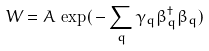Convert formula to latex. <formula><loc_0><loc_0><loc_500><loc_500>W = A \, \exp ( \, - \sum _ { q } \gamma _ { q } \beta _ { q } ^ { \dag } \beta _ { q } )</formula> 